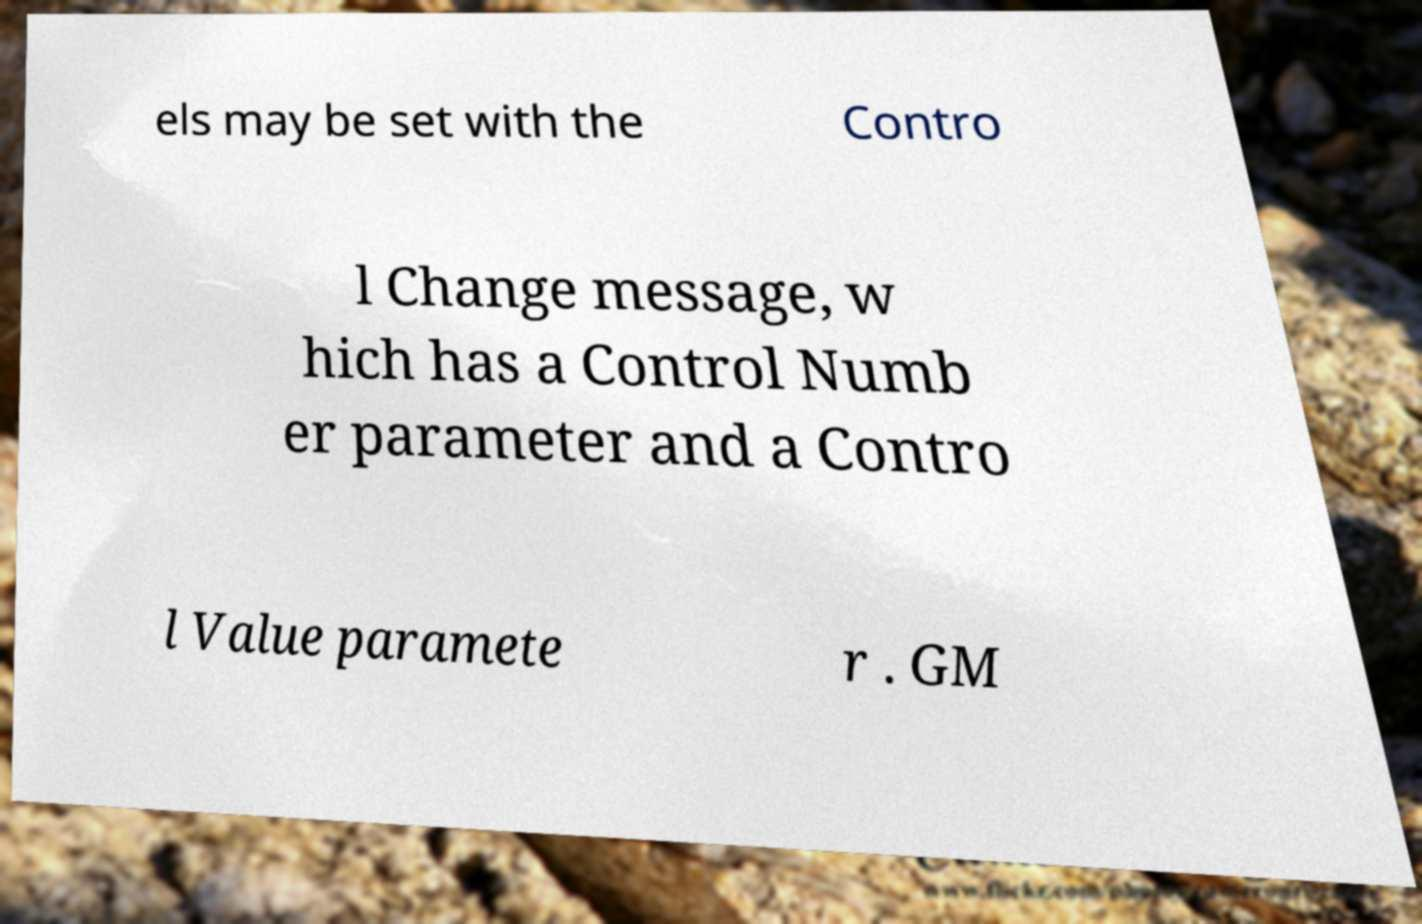For documentation purposes, I need the text within this image transcribed. Could you provide that? els may be set with the Contro l Change message, w hich has a Control Numb er parameter and a Contro l Value paramete r . GM 